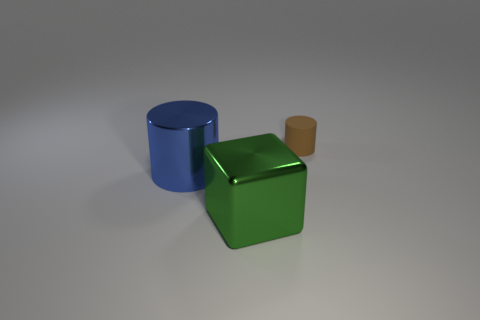Add 3 cyan metallic objects. How many objects exist? 6 Subtract all yellow spheres. How many brown cylinders are left? 1 Subtract all brown cylinders. How many cylinders are left? 1 Subtract 1 cylinders. How many cylinders are left? 1 Subtract all purple cylinders. Subtract all red cubes. How many cylinders are left? 2 Add 3 large yellow metallic spheres. How many large yellow metallic spheres exist? 3 Subtract 1 blue cylinders. How many objects are left? 2 Subtract all cylinders. How many objects are left? 1 Subtract all small rubber objects. Subtract all small blue metallic cylinders. How many objects are left? 2 Add 2 large metallic cylinders. How many large metallic cylinders are left? 3 